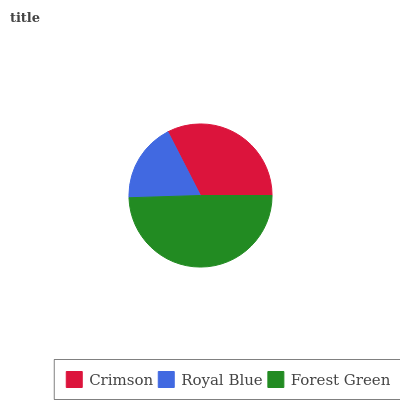Is Royal Blue the minimum?
Answer yes or no. Yes. Is Forest Green the maximum?
Answer yes or no. Yes. Is Forest Green the minimum?
Answer yes or no. No. Is Royal Blue the maximum?
Answer yes or no. No. Is Forest Green greater than Royal Blue?
Answer yes or no. Yes. Is Royal Blue less than Forest Green?
Answer yes or no. Yes. Is Royal Blue greater than Forest Green?
Answer yes or no. No. Is Forest Green less than Royal Blue?
Answer yes or no. No. Is Crimson the high median?
Answer yes or no. Yes. Is Crimson the low median?
Answer yes or no. Yes. Is Royal Blue the high median?
Answer yes or no. No. Is Forest Green the low median?
Answer yes or no. No. 